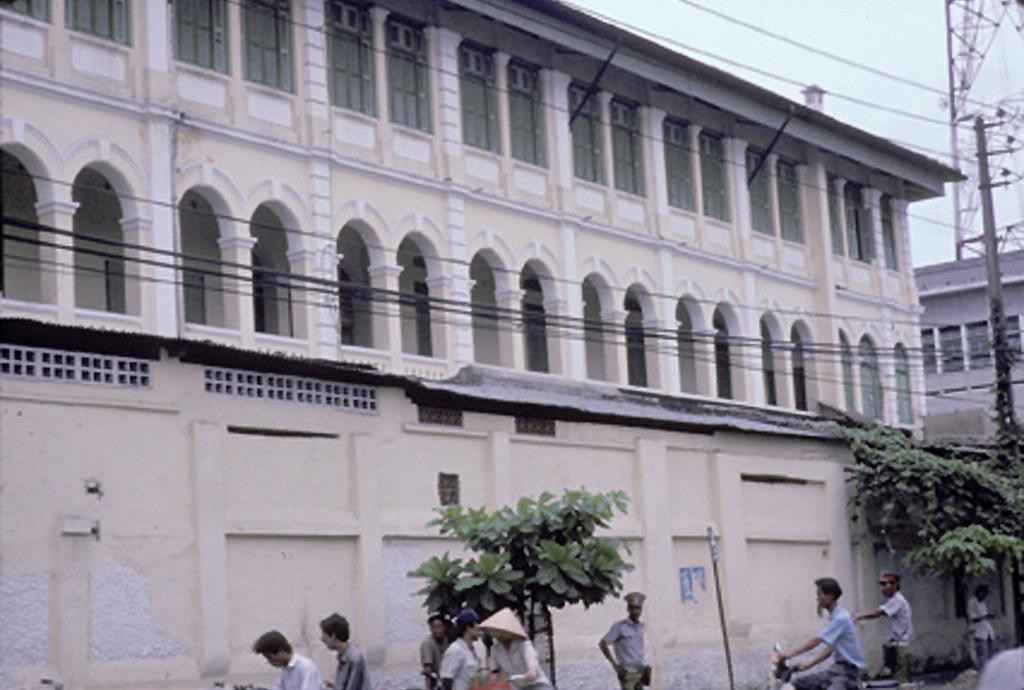What is located at the bottom of the image? There are many people and trees at the bottom of the image. What can be seen in the middle of the image? There are buildings, sheds, electric poles, and cables visible in the middle of the image. What is visible in the image besides the structures and people? The sky is visible in the image. What type of locket is hanging from the electric pole in the image? There is no locket present on the electric pole in the image. How does the wealth of the people in the image affect the structures around them? The image does not provide information about the wealth of the people, so we cannot determine how it affects the structures around them. 